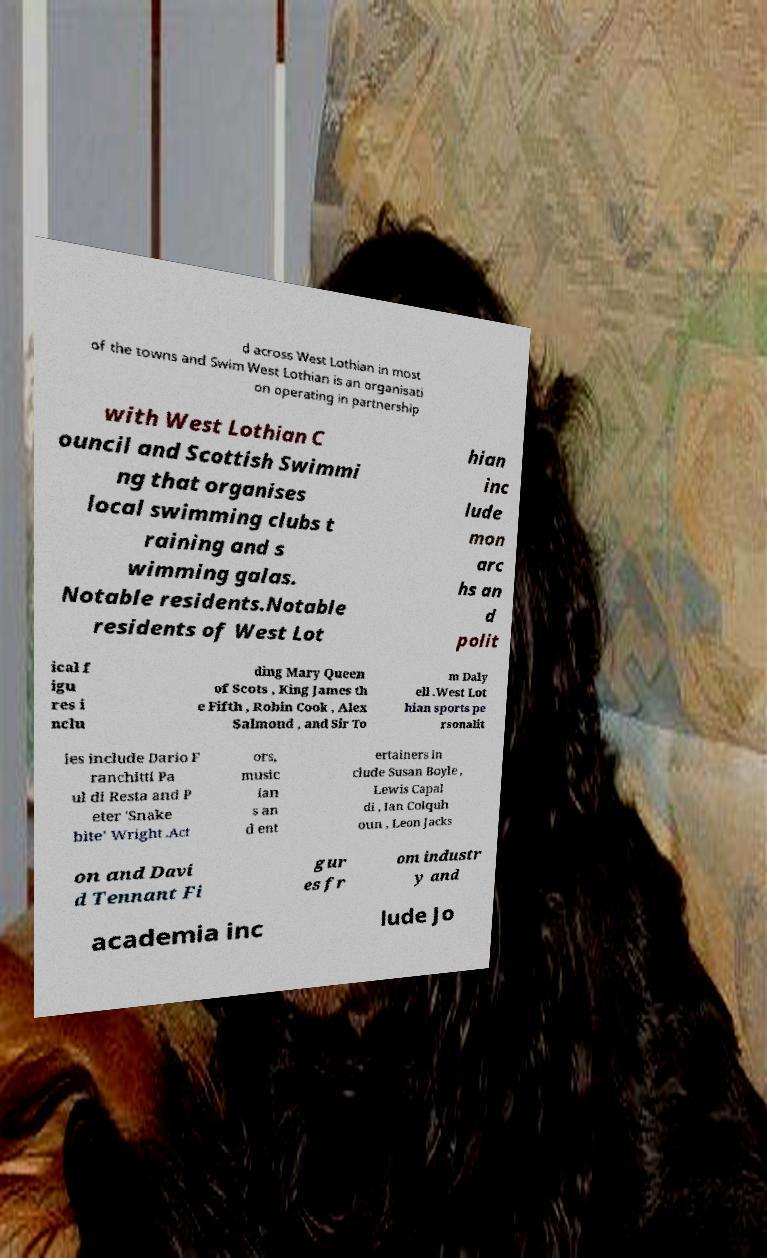What messages or text are displayed in this image? I need them in a readable, typed format. d across West Lothian in most of the towns and Swim West Lothian is an organisati on operating in partnership with West Lothian C ouncil and Scottish Swimmi ng that organises local swimming clubs t raining and s wimming galas. Notable residents.Notable residents of West Lot hian inc lude mon arc hs an d polit ical f igu res i nclu ding Mary Queen of Scots , King James th e Fifth , Robin Cook , Alex Salmond , and Sir To m Daly ell .West Lot hian sports pe rsonalit ies include Dario F ranchitti Pa ul di Resta and P eter 'Snake bite' Wright .Act ors, music ian s an d ent ertainers in clude Susan Boyle , Lewis Capal di , Ian Colquh oun , Leon Jacks on and Davi d Tennant Fi gur es fr om industr y and academia inc lude Jo 